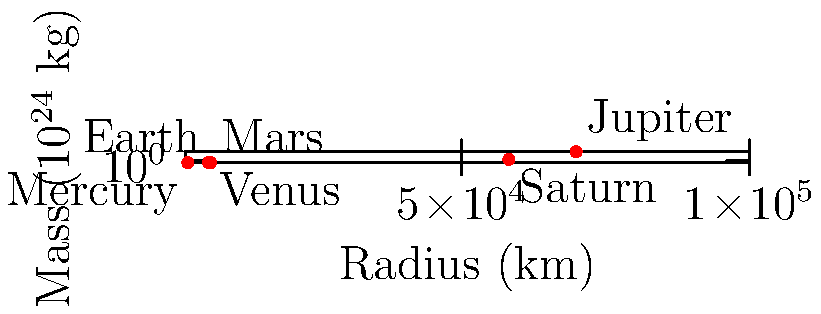Given the graph showing the mass and radius of various celestial bodies, calculate the escape velocity for a new exoplanet with a mass of $4.5 \times 10^{24}$ kg and a radius of 7000 km. How does this compare to Earth's escape velocity? (Use $G = 6.67 \times 10^{-11} \text{ m}^3 \text{ kg}^{-1} \text{ s}^{-2}$) To solve this problem, we'll follow these steps:

1) The formula for escape velocity is:

   $$v_e = \sqrt{\frac{2GM}{R}}$$

   where $G$ is the gravitational constant, $M$ is the mass of the celestial body, and $R$ is its radius.

2) For the new exoplanet:
   $M = 4.5 \times 10^{24}$ kg
   $R = 7000$ km = $7 \times 10^6$ m

3) Substituting these values into the equation:

   $$v_e = \sqrt{\frac{2 \times (6.67 \times 10^{-11}) \times (4.5 \times 10^{24})}{7 \times 10^6}}$$

4) Simplifying:

   $$v_e = \sqrt{\frac{60.03 \times 10^{13}}{7 \times 10^6}} = \sqrt{8.58 \times 10^7} \approx 9.26 \times 10^3 \text{ m/s}$$

5) Converting to km/s:

   $$v_e \approx 9.26 \text{ km/s}$$

6) Earth's escape velocity (from the data provided in the graph) is 11.2 km/s.

7) Comparing:
   $9.26 \text{ km/s} < 11.2 \text{ km/s}$

Therefore, the escape velocity of the new exoplanet is about 17.3% lower than Earth's escape velocity.
Answer: 9.26 km/s, 17.3% lower than Earth's 